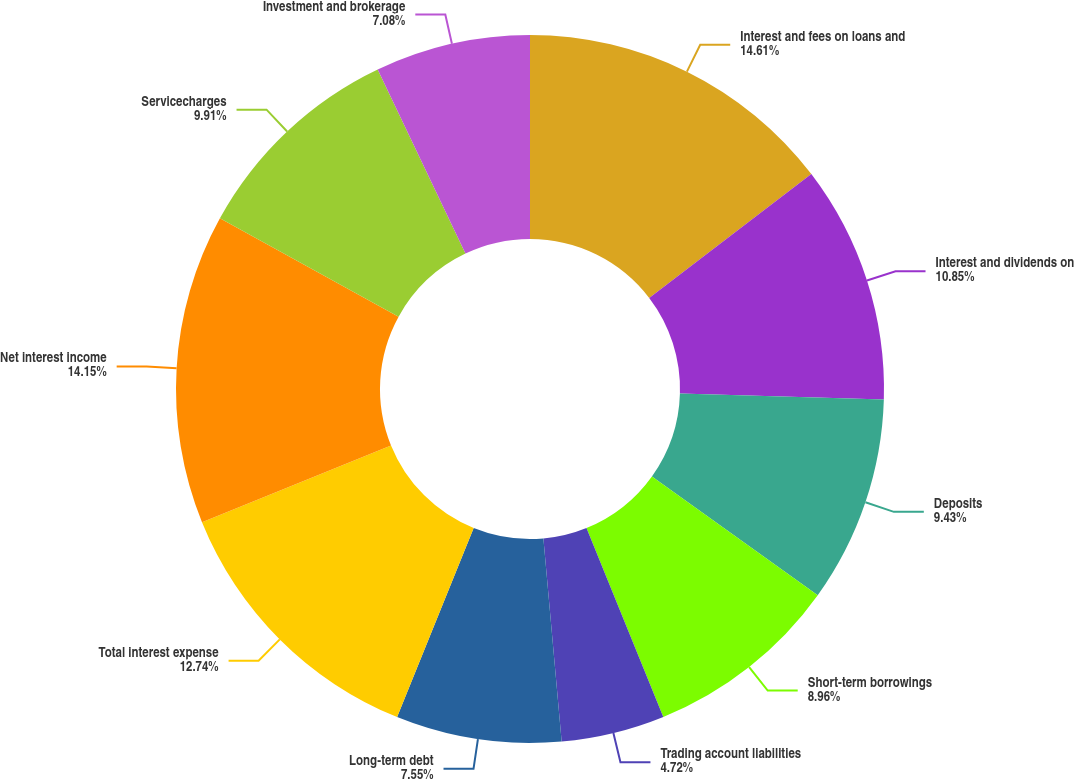<chart> <loc_0><loc_0><loc_500><loc_500><pie_chart><fcel>Interest and fees on loans and<fcel>Interest and dividends on<fcel>Deposits<fcel>Short-term borrowings<fcel>Trading account liabilities<fcel>Long-term debt<fcel>Total interest expense<fcel>Net interest income<fcel>Servicecharges<fcel>Investment and brokerage<nl><fcel>14.62%<fcel>10.85%<fcel>9.43%<fcel>8.96%<fcel>4.72%<fcel>7.55%<fcel>12.74%<fcel>14.15%<fcel>9.91%<fcel>7.08%<nl></chart> 